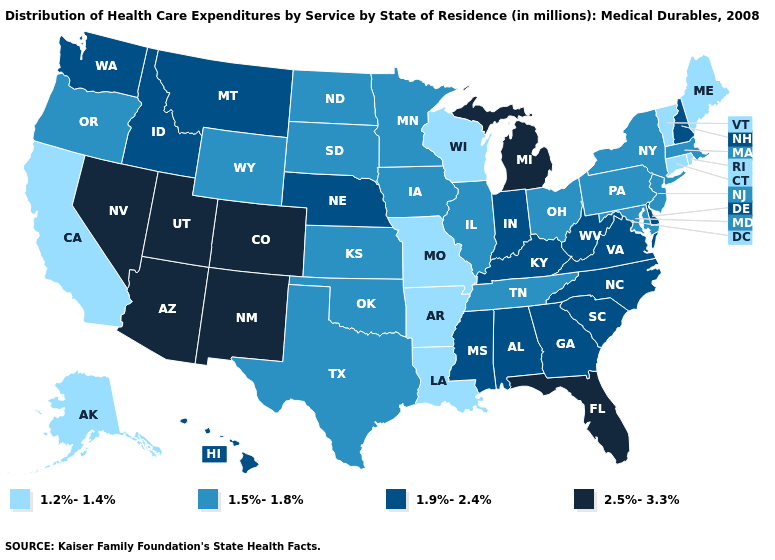Does Florida have the highest value in the South?
Concise answer only. Yes. Among the states that border Kansas , does Nebraska have the highest value?
Give a very brief answer. No. Which states hav the highest value in the West?
Concise answer only. Arizona, Colorado, Nevada, New Mexico, Utah. What is the value of Ohio?
Concise answer only. 1.5%-1.8%. Among the states that border Pennsylvania , which have the highest value?
Write a very short answer. Delaware, West Virginia. Which states hav the highest value in the West?
Be succinct. Arizona, Colorado, Nevada, New Mexico, Utah. Name the states that have a value in the range 1.9%-2.4%?
Answer briefly. Alabama, Delaware, Georgia, Hawaii, Idaho, Indiana, Kentucky, Mississippi, Montana, Nebraska, New Hampshire, North Carolina, South Carolina, Virginia, Washington, West Virginia. Does the first symbol in the legend represent the smallest category?
Quick response, please. Yes. What is the value of West Virginia?
Be succinct. 1.9%-2.4%. What is the lowest value in the West?
Write a very short answer. 1.2%-1.4%. What is the highest value in the MidWest ?
Concise answer only. 2.5%-3.3%. Name the states that have a value in the range 1.5%-1.8%?
Give a very brief answer. Illinois, Iowa, Kansas, Maryland, Massachusetts, Minnesota, New Jersey, New York, North Dakota, Ohio, Oklahoma, Oregon, Pennsylvania, South Dakota, Tennessee, Texas, Wyoming. How many symbols are there in the legend?
Quick response, please. 4. Does Utah have the highest value in the West?
Short answer required. Yes. 